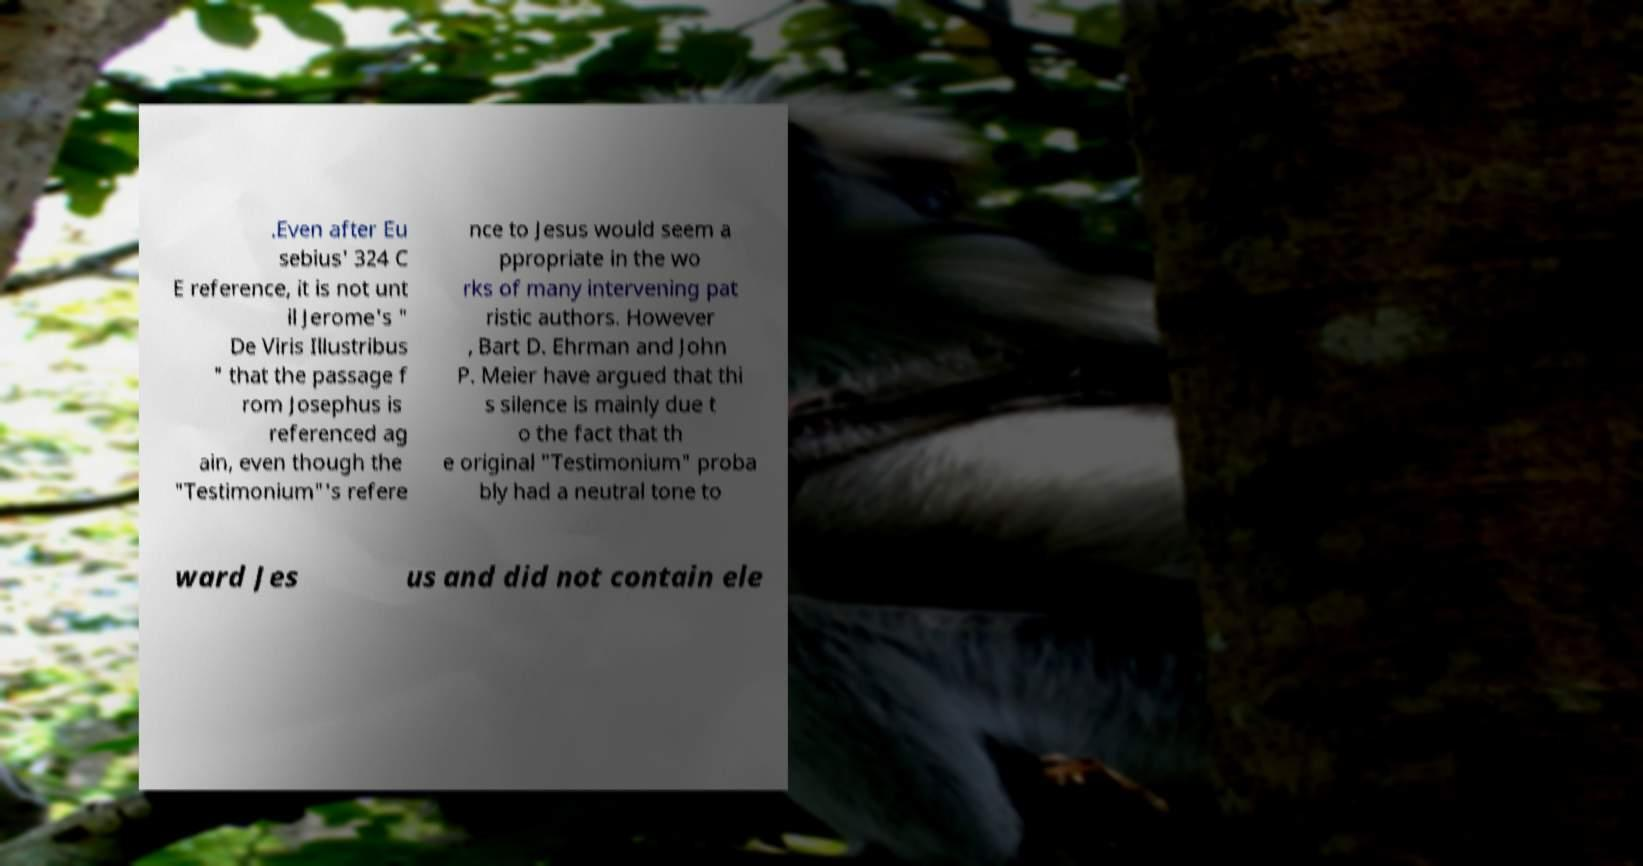Can you accurately transcribe the text from the provided image for me? .Even after Eu sebius' 324 C E reference, it is not unt il Jerome's " De Viris Illustribus " that the passage f rom Josephus is referenced ag ain, even though the "Testimonium"'s refere nce to Jesus would seem a ppropriate in the wo rks of many intervening pat ristic authors. However , Bart D. Ehrman and John P. Meier have argued that thi s silence is mainly due t o the fact that th e original "Testimonium" proba bly had a neutral tone to ward Jes us and did not contain ele 